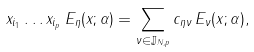Convert formula to latex. <formula><loc_0><loc_0><loc_500><loc_500>x _ { i _ { 1 } } \dots x _ { i _ { p } } \, E _ { \eta } ( x ; \alpha ) = \sum _ { \nu \in { \mathbb { J } } _ { N , p } } c _ { \eta \nu } \, E _ { \nu } ( x ; \alpha ) ,</formula> 